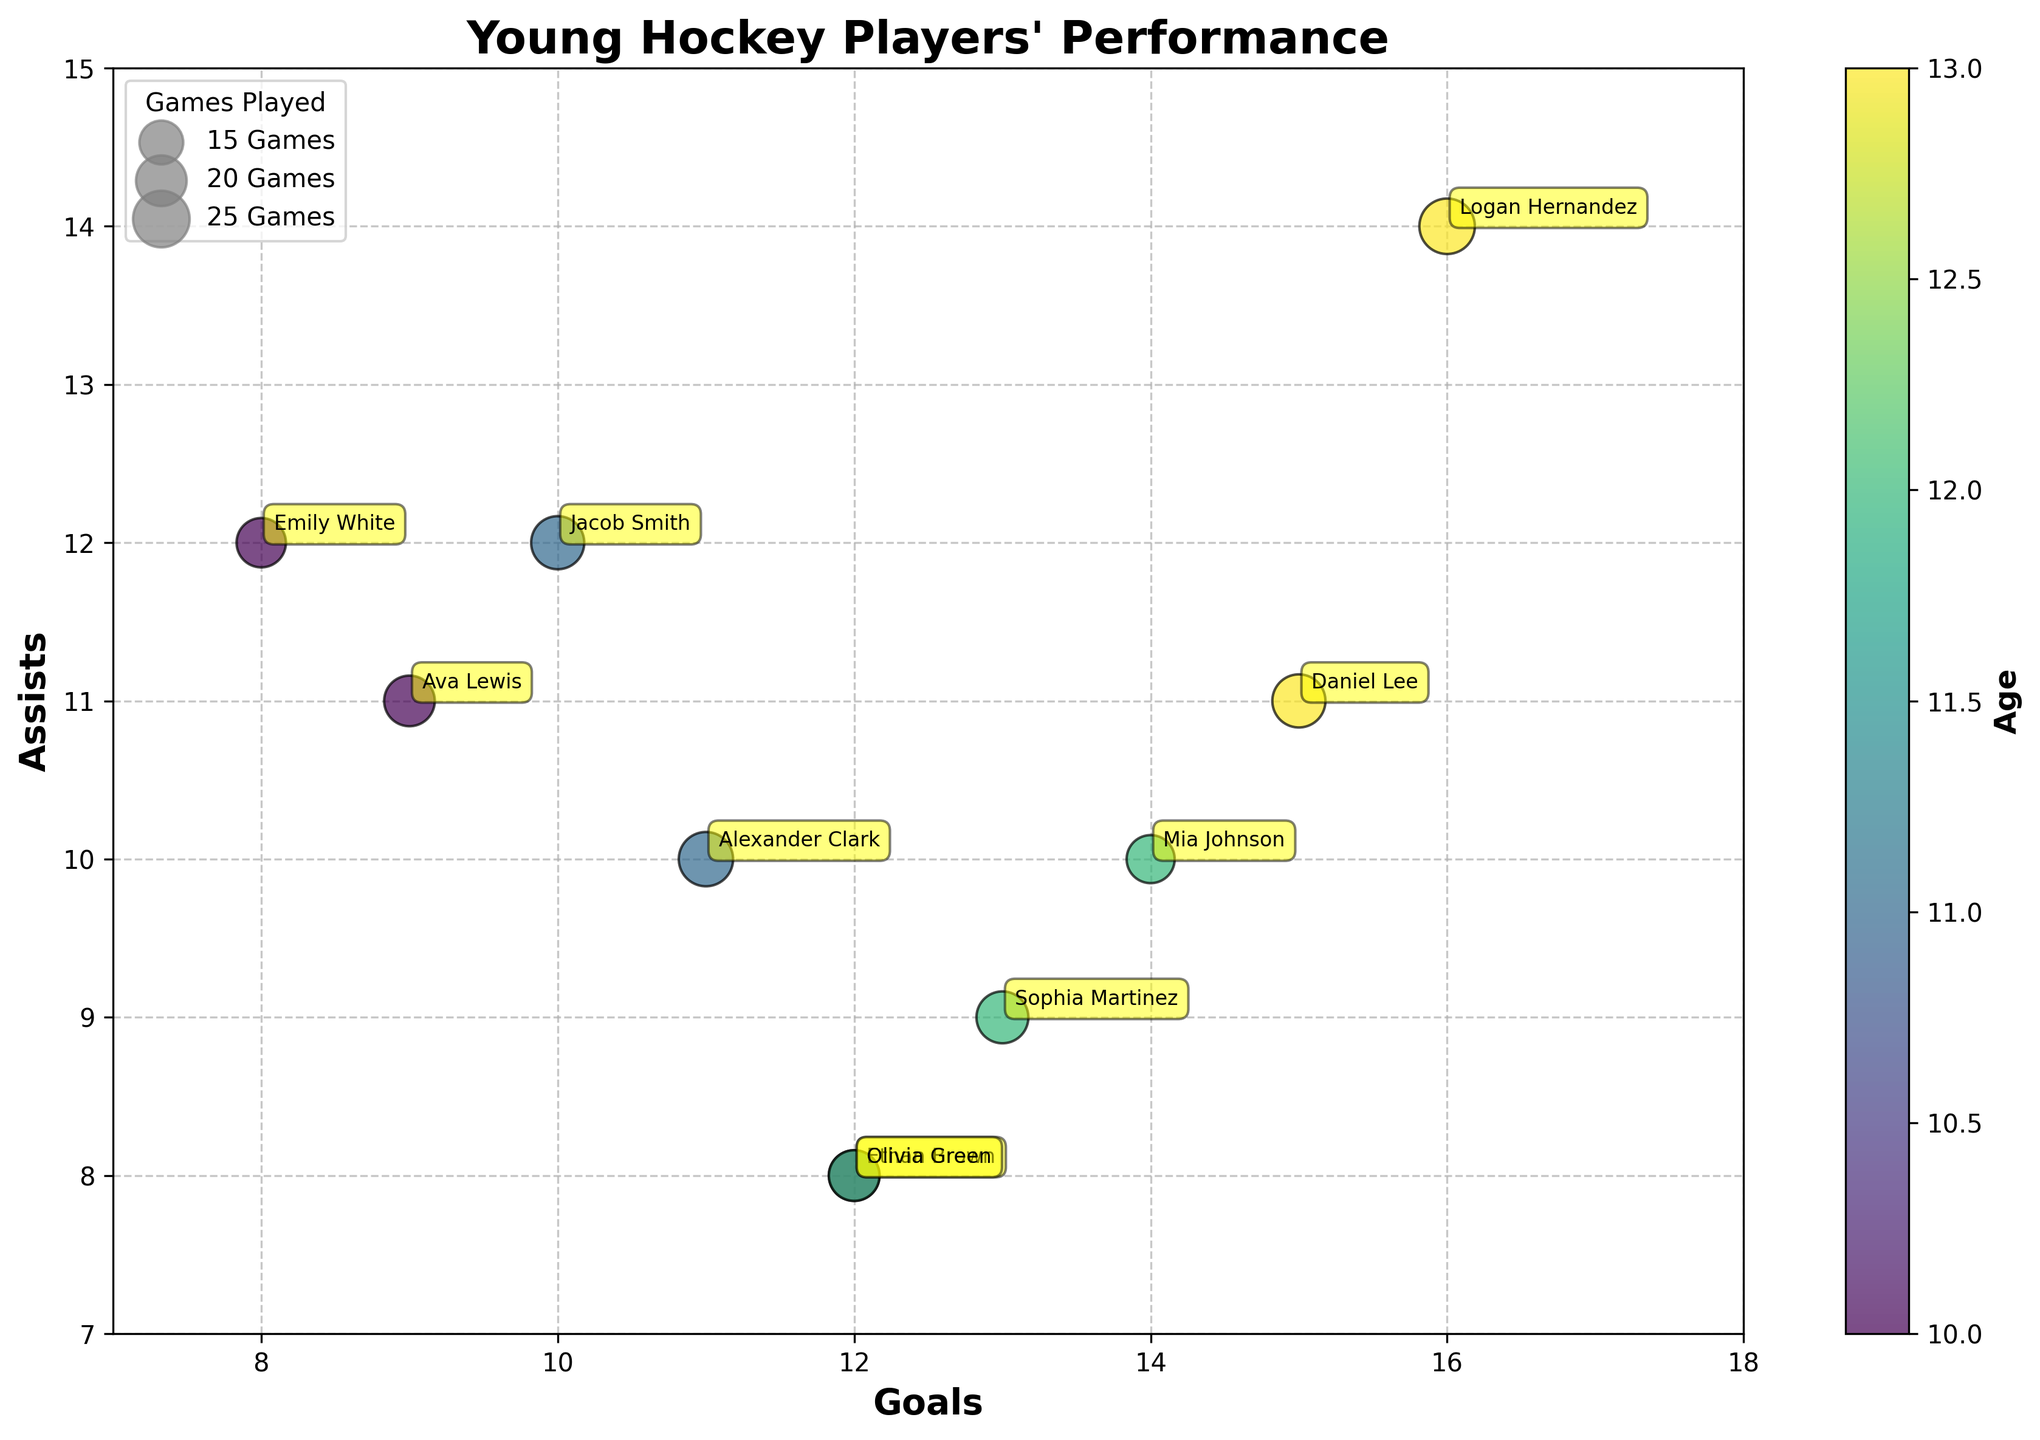What's the title of the chart? The title of the chart is displayed prominently at the top of the figure.
Answer: Young Hockey Players' Performance Which player has the highest number of goals? By looking at the horizontal axis, you can identify that Logan Hernandez has the highest number of goals (16) among the players.
Answer: Logan Hernandez What is the color bar label? The color bar on the right side of the plot indicates the age of the players. The label of the color bar reads 'Age'.
Answer: Age How many assists does Ava Lewis have? Ava Lewis's bubble can be located in the chart, and by looking at the vertical axis where her bubble is positioned, you can see that she has 11 assists.
Answer: 11 How many players have goals equal to or above 14? By counting the number of bubbles that are on or to the right of the vertical line for 14 goals, you find that there are two players (Mia Johnson and Logan Hernandez).
Answer: 2 Which player is represented by the largest bubble? The legend shows that the bubble size represents 'Games Played'. The largest bubble correlates with the highest number of games played, and Logan Hernandez's bubble is the largest.
Answer: Logan Hernandez What are the ages of players who have 20 points? By locating the bubbles along the 20 points value, the color bar can be used to determine the ages. Ethan Brown, Ava Lewis, and Olivia Green are all 10 and have 20 points.
Answer: 10 Who has a higher ratio of assists to goals, Jacob Smith or Alexander Clark? Calculate the ratio for both players; Jacob Smith has 1.2 (12 assists/10 goals) and Alexander Clark has 0.91 (10 assists/11 goals).
Answer: Jacob Smith How many players have played 20 games or more? By identifying bubble sizes in the legend, count the bubbles that correspond to 20 games or more. There are 7 players (Ethan Brown, Jacob Smith, Ava Lewis, Emily White, Logan Hernandez, Daniel Lee, Alexander Clark).
Answer: 7 Which player in the chart has the fewest penalty minutes? By checking each player's annotated bubble, Sophia Martinez with 4 penalty minutes has the fewest.
Answer: Sophia Martinez 